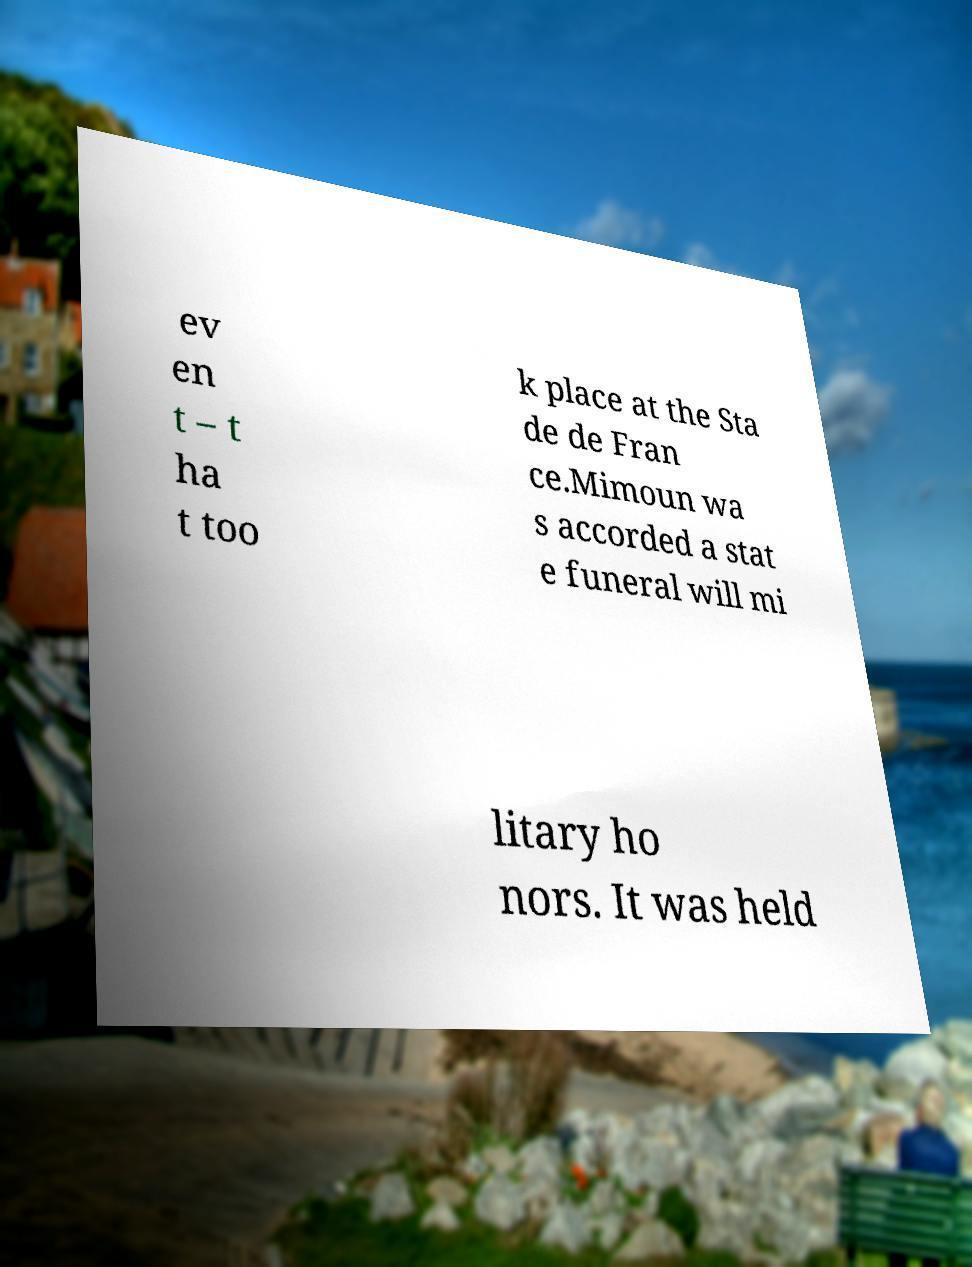I need the written content from this picture converted into text. Can you do that? ev en t – t ha t too k place at the Sta de de Fran ce.Mimoun wa s accorded a stat e funeral will mi litary ho nors. It was held 